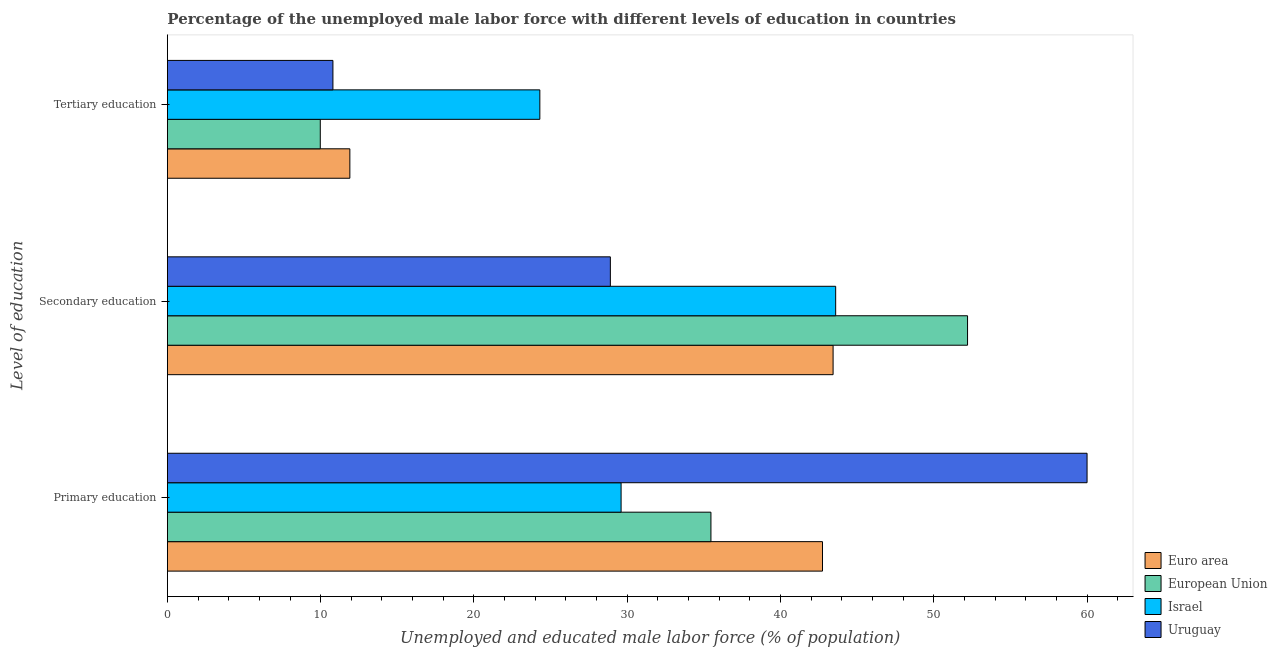Are the number of bars on each tick of the Y-axis equal?
Provide a succinct answer. Yes. How many bars are there on the 3rd tick from the bottom?
Your answer should be compact. 4. What is the label of the 2nd group of bars from the top?
Make the answer very short. Secondary education. What is the percentage of male labor force who received secondary education in Euro area?
Offer a very short reply. 43.43. Across all countries, what is the maximum percentage of male labor force who received primary education?
Give a very brief answer. 60. Across all countries, what is the minimum percentage of male labor force who received secondary education?
Make the answer very short. 28.9. In which country was the percentage of male labor force who received primary education maximum?
Your response must be concise. Uruguay. In which country was the percentage of male labor force who received secondary education minimum?
Ensure brevity in your answer.  Uruguay. What is the total percentage of male labor force who received primary education in the graph?
Your answer should be very brief. 167.8. What is the difference between the percentage of male labor force who received secondary education in Israel and that in Uruguay?
Give a very brief answer. 14.7. What is the difference between the percentage of male labor force who received primary education in European Union and the percentage of male labor force who received secondary education in Euro area?
Your answer should be very brief. -7.97. What is the average percentage of male labor force who received tertiary education per country?
Provide a short and direct response. 14.24. What is the difference between the percentage of male labor force who received tertiary education and percentage of male labor force who received primary education in Euro area?
Ensure brevity in your answer.  -30.84. In how many countries, is the percentage of male labor force who received primary education greater than 14 %?
Ensure brevity in your answer.  4. What is the ratio of the percentage of male labor force who received tertiary education in Euro area to that in Israel?
Your answer should be compact. 0.49. What is the difference between the highest and the second highest percentage of male labor force who received primary education?
Your response must be concise. 17.26. What is the difference between the highest and the lowest percentage of male labor force who received primary education?
Offer a terse response. 30.4. In how many countries, is the percentage of male labor force who received secondary education greater than the average percentage of male labor force who received secondary education taken over all countries?
Offer a terse response. 3. What does the 2nd bar from the top in Secondary education represents?
Provide a succinct answer. Israel. What does the 4th bar from the bottom in Secondary education represents?
Make the answer very short. Uruguay. Is it the case that in every country, the sum of the percentage of male labor force who received primary education and percentage of male labor force who received secondary education is greater than the percentage of male labor force who received tertiary education?
Your answer should be very brief. Yes. Are all the bars in the graph horizontal?
Offer a terse response. Yes. How many countries are there in the graph?
Keep it short and to the point. 4. What is the difference between two consecutive major ticks on the X-axis?
Your answer should be compact. 10. Are the values on the major ticks of X-axis written in scientific E-notation?
Offer a very short reply. No. Where does the legend appear in the graph?
Keep it short and to the point. Bottom right. How many legend labels are there?
Provide a short and direct response. 4. How are the legend labels stacked?
Provide a short and direct response. Vertical. What is the title of the graph?
Provide a succinct answer. Percentage of the unemployed male labor force with different levels of education in countries. Does "Iceland" appear as one of the legend labels in the graph?
Your response must be concise. No. What is the label or title of the X-axis?
Provide a short and direct response. Unemployed and educated male labor force (% of population). What is the label or title of the Y-axis?
Provide a succinct answer. Level of education. What is the Unemployed and educated male labor force (% of population) in Euro area in Primary education?
Keep it short and to the point. 42.74. What is the Unemployed and educated male labor force (% of population) in European Union in Primary education?
Provide a short and direct response. 35.46. What is the Unemployed and educated male labor force (% of population) in Israel in Primary education?
Offer a very short reply. 29.6. What is the Unemployed and educated male labor force (% of population) of Euro area in Secondary education?
Provide a succinct answer. 43.43. What is the Unemployed and educated male labor force (% of population) of European Union in Secondary education?
Your response must be concise. 52.2. What is the Unemployed and educated male labor force (% of population) in Israel in Secondary education?
Offer a terse response. 43.6. What is the Unemployed and educated male labor force (% of population) of Uruguay in Secondary education?
Your response must be concise. 28.9. What is the Unemployed and educated male labor force (% of population) of Euro area in Tertiary education?
Your response must be concise. 11.9. What is the Unemployed and educated male labor force (% of population) of European Union in Tertiary education?
Keep it short and to the point. 9.97. What is the Unemployed and educated male labor force (% of population) in Israel in Tertiary education?
Provide a short and direct response. 24.3. What is the Unemployed and educated male labor force (% of population) of Uruguay in Tertiary education?
Give a very brief answer. 10.8. Across all Level of education, what is the maximum Unemployed and educated male labor force (% of population) in Euro area?
Offer a terse response. 43.43. Across all Level of education, what is the maximum Unemployed and educated male labor force (% of population) of European Union?
Make the answer very short. 52.2. Across all Level of education, what is the maximum Unemployed and educated male labor force (% of population) in Israel?
Your answer should be very brief. 43.6. Across all Level of education, what is the minimum Unemployed and educated male labor force (% of population) in Euro area?
Provide a succinct answer. 11.9. Across all Level of education, what is the minimum Unemployed and educated male labor force (% of population) of European Union?
Your answer should be compact. 9.97. Across all Level of education, what is the minimum Unemployed and educated male labor force (% of population) in Israel?
Give a very brief answer. 24.3. Across all Level of education, what is the minimum Unemployed and educated male labor force (% of population) in Uruguay?
Your answer should be very brief. 10.8. What is the total Unemployed and educated male labor force (% of population) in Euro area in the graph?
Provide a succinct answer. 98.08. What is the total Unemployed and educated male labor force (% of population) in European Union in the graph?
Offer a terse response. 97.64. What is the total Unemployed and educated male labor force (% of population) of Israel in the graph?
Your answer should be compact. 97.5. What is the total Unemployed and educated male labor force (% of population) in Uruguay in the graph?
Your answer should be compact. 99.7. What is the difference between the Unemployed and educated male labor force (% of population) of Euro area in Primary education and that in Secondary education?
Provide a succinct answer. -0.69. What is the difference between the Unemployed and educated male labor force (% of population) of European Union in Primary education and that in Secondary education?
Offer a very short reply. -16.74. What is the difference between the Unemployed and educated male labor force (% of population) in Israel in Primary education and that in Secondary education?
Offer a very short reply. -14. What is the difference between the Unemployed and educated male labor force (% of population) of Uruguay in Primary education and that in Secondary education?
Provide a short and direct response. 31.1. What is the difference between the Unemployed and educated male labor force (% of population) of Euro area in Primary education and that in Tertiary education?
Provide a succinct answer. 30.84. What is the difference between the Unemployed and educated male labor force (% of population) in European Union in Primary education and that in Tertiary education?
Provide a short and direct response. 25.49. What is the difference between the Unemployed and educated male labor force (% of population) in Israel in Primary education and that in Tertiary education?
Give a very brief answer. 5.3. What is the difference between the Unemployed and educated male labor force (% of population) of Uruguay in Primary education and that in Tertiary education?
Your response must be concise. 49.2. What is the difference between the Unemployed and educated male labor force (% of population) in Euro area in Secondary education and that in Tertiary education?
Make the answer very short. 31.53. What is the difference between the Unemployed and educated male labor force (% of population) in European Union in Secondary education and that in Tertiary education?
Your answer should be very brief. 42.23. What is the difference between the Unemployed and educated male labor force (% of population) in Israel in Secondary education and that in Tertiary education?
Your answer should be very brief. 19.3. What is the difference between the Unemployed and educated male labor force (% of population) in Euro area in Primary education and the Unemployed and educated male labor force (% of population) in European Union in Secondary education?
Keep it short and to the point. -9.46. What is the difference between the Unemployed and educated male labor force (% of population) in Euro area in Primary education and the Unemployed and educated male labor force (% of population) in Israel in Secondary education?
Give a very brief answer. -0.86. What is the difference between the Unemployed and educated male labor force (% of population) of Euro area in Primary education and the Unemployed and educated male labor force (% of population) of Uruguay in Secondary education?
Your answer should be very brief. 13.84. What is the difference between the Unemployed and educated male labor force (% of population) in European Union in Primary education and the Unemployed and educated male labor force (% of population) in Israel in Secondary education?
Keep it short and to the point. -8.14. What is the difference between the Unemployed and educated male labor force (% of population) of European Union in Primary education and the Unemployed and educated male labor force (% of population) of Uruguay in Secondary education?
Your answer should be compact. 6.56. What is the difference between the Unemployed and educated male labor force (% of population) in Israel in Primary education and the Unemployed and educated male labor force (% of population) in Uruguay in Secondary education?
Make the answer very short. 0.7. What is the difference between the Unemployed and educated male labor force (% of population) of Euro area in Primary education and the Unemployed and educated male labor force (% of population) of European Union in Tertiary education?
Make the answer very short. 32.77. What is the difference between the Unemployed and educated male labor force (% of population) of Euro area in Primary education and the Unemployed and educated male labor force (% of population) of Israel in Tertiary education?
Your response must be concise. 18.44. What is the difference between the Unemployed and educated male labor force (% of population) in Euro area in Primary education and the Unemployed and educated male labor force (% of population) in Uruguay in Tertiary education?
Provide a succinct answer. 31.94. What is the difference between the Unemployed and educated male labor force (% of population) in European Union in Primary education and the Unemployed and educated male labor force (% of population) in Israel in Tertiary education?
Provide a succinct answer. 11.16. What is the difference between the Unemployed and educated male labor force (% of population) of European Union in Primary education and the Unemployed and educated male labor force (% of population) of Uruguay in Tertiary education?
Give a very brief answer. 24.66. What is the difference between the Unemployed and educated male labor force (% of population) in Israel in Primary education and the Unemployed and educated male labor force (% of population) in Uruguay in Tertiary education?
Offer a very short reply. 18.8. What is the difference between the Unemployed and educated male labor force (% of population) in Euro area in Secondary education and the Unemployed and educated male labor force (% of population) in European Union in Tertiary education?
Ensure brevity in your answer.  33.46. What is the difference between the Unemployed and educated male labor force (% of population) in Euro area in Secondary education and the Unemployed and educated male labor force (% of population) in Israel in Tertiary education?
Keep it short and to the point. 19.13. What is the difference between the Unemployed and educated male labor force (% of population) in Euro area in Secondary education and the Unemployed and educated male labor force (% of population) in Uruguay in Tertiary education?
Give a very brief answer. 32.63. What is the difference between the Unemployed and educated male labor force (% of population) of European Union in Secondary education and the Unemployed and educated male labor force (% of population) of Israel in Tertiary education?
Keep it short and to the point. 27.9. What is the difference between the Unemployed and educated male labor force (% of population) of European Union in Secondary education and the Unemployed and educated male labor force (% of population) of Uruguay in Tertiary education?
Keep it short and to the point. 41.4. What is the difference between the Unemployed and educated male labor force (% of population) in Israel in Secondary education and the Unemployed and educated male labor force (% of population) in Uruguay in Tertiary education?
Your answer should be compact. 32.8. What is the average Unemployed and educated male labor force (% of population) in Euro area per Level of education?
Your answer should be very brief. 32.69. What is the average Unemployed and educated male labor force (% of population) in European Union per Level of education?
Make the answer very short. 32.55. What is the average Unemployed and educated male labor force (% of population) of Israel per Level of education?
Offer a very short reply. 32.5. What is the average Unemployed and educated male labor force (% of population) in Uruguay per Level of education?
Your response must be concise. 33.23. What is the difference between the Unemployed and educated male labor force (% of population) in Euro area and Unemployed and educated male labor force (% of population) in European Union in Primary education?
Provide a short and direct response. 7.28. What is the difference between the Unemployed and educated male labor force (% of population) in Euro area and Unemployed and educated male labor force (% of population) in Israel in Primary education?
Give a very brief answer. 13.14. What is the difference between the Unemployed and educated male labor force (% of population) in Euro area and Unemployed and educated male labor force (% of population) in Uruguay in Primary education?
Ensure brevity in your answer.  -17.26. What is the difference between the Unemployed and educated male labor force (% of population) of European Union and Unemployed and educated male labor force (% of population) of Israel in Primary education?
Offer a terse response. 5.86. What is the difference between the Unemployed and educated male labor force (% of population) in European Union and Unemployed and educated male labor force (% of population) in Uruguay in Primary education?
Make the answer very short. -24.54. What is the difference between the Unemployed and educated male labor force (% of population) in Israel and Unemployed and educated male labor force (% of population) in Uruguay in Primary education?
Ensure brevity in your answer.  -30.4. What is the difference between the Unemployed and educated male labor force (% of population) in Euro area and Unemployed and educated male labor force (% of population) in European Union in Secondary education?
Your answer should be compact. -8.77. What is the difference between the Unemployed and educated male labor force (% of population) of Euro area and Unemployed and educated male labor force (% of population) of Israel in Secondary education?
Offer a very short reply. -0.17. What is the difference between the Unemployed and educated male labor force (% of population) in Euro area and Unemployed and educated male labor force (% of population) in Uruguay in Secondary education?
Keep it short and to the point. 14.53. What is the difference between the Unemployed and educated male labor force (% of population) of European Union and Unemployed and educated male labor force (% of population) of Israel in Secondary education?
Keep it short and to the point. 8.6. What is the difference between the Unemployed and educated male labor force (% of population) of European Union and Unemployed and educated male labor force (% of population) of Uruguay in Secondary education?
Make the answer very short. 23.3. What is the difference between the Unemployed and educated male labor force (% of population) of Israel and Unemployed and educated male labor force (% of population) of Uruguay in Secondary education?
Keep it short and to the point. 14.7. What is the difference between the Unemployed and educated male labor force (% of population) in Euro area and Unemployed and educated male labor force (% of population) in European Union in Tertiary education?
Give a very brief answer. 1.93. What is the difference between the Unemployed and educated male labor force (% of population) of Euro area and Unemployed and educated male labor force (% of population) of Israel in Tertiary education?
Provide a short and direct response. -12.39. What is the difference between the Unemployed and educated male labor force (% of population) of Euro area and Unemployed and educated male labor force (% of population) of Uruguay in Tertiary education?
Ensure brevity in your answer.  1.1. What is the difference between the Unemployed and educated male labor force (% of population) in European Union and Unemployed and educated male labor force (% of population) in Israel in Tertiary education?
Provide a short and direct response. -14.33. What is the difference between the Unemployed and educated male labor force (% of population) in European Union and Unemployed and educated male labor force (% of population) in Uruguay in Tertiary education?
Make the answer very short. -0.83. What is the difference between the Unemployed and educated male labor force (% of population) in Israel and Unemployed and educated male labor force (% of population) in Uruguay in Tertiary education?
Provide a succinct answer. 13.5. What is the ratio of the Unemployed and educated male labor force (% of population) of Euro area in Primary education to that in Secondary education?
Your response must be concise. 0.98. What is the ratio of the Unemployed and educated male labor force (% of population) in European Union in Primary education to that in Secondary education?
Provide a succinct answer. 0.68. What is the ratio of the Unemployed and educated male labor force (% of population) in Israel in Primary education to that in Secondary education?
Provide a succinct answer. 0.68. What is the ratio of the Unemployed and educated male labor force (% of population) of Uruguay in Primary education to that in Secondary education?
Ensure brevity in your answer.  2.08. What is the ratio of the Unemployed and educated male labor force (% of population) of Euro area in Primary education to that in Tertiary education?
Offer a very short reply. 3.59. What is the ratio of the Unemployed and educated male labor force (% of population) of European Union in Primary education to that in Tertiary education?
Your answer should be very brief. 3.56. What is the ratio of the Unemployed and educated male labor force (% of population) in Israel in Primary education to that in Tertiary education?
Provide a short and direct response. 1.22. What is the ratio of the Unemployed and educated male labor force (% of population) of Uruguay in Primary education to that in Tertiary education?
Your answer should be compact. 5.56. What is the ratio of the Unemployed and educated male labor force (% of population) of Euro area in Secondary education to that in Tertiary education?
Your response must be concise. 3.65. What is the ratio of the Unemployed and educated male labor force (% of population) in European Union in Secondary education to that in Tertiary education?
Your answer should be compact. 5.23. What is the ratio of the Unemployed and educated male labor force (% of population) in Israel in Secondary education to that in Tertiary education?
Make the answer very short. 1.79. What is the ratio of the Unemployed and educated male labor force (% of population) in Uruguay in Secondary education to that in Tertiary education?
Your response must be concise. 2.68. What is the difference between the highest and the second highest Unemployed and educated male labor force (% of population) of Euro area?
Your answer should be very brief. 0.69. What is the difference between the highest and the second highest Unemployed and educated male labor force (% of population) of European Union?
Your answer should be very brief. 16.74. What is the difference between the highest and the second highest Unemployed and educated male labor force (% of population) in Israel?
Provide a succinct answer. 14. What is the difference between the highest and the second highest Unemployed and educated male labor force (% of population) of Uruguay?
Provide a short and direct response. 31.1. What is the difference between the highest and the lowest Unemployed and educated male labor force (% of population) in Euro area?
Your response must be concise. 31.53. What is the difference between the highest and the lowest Unemployed and educated male labor force (% of population) in European Union?
Make the answer very short. 42.23. What is the difference between the highest and the lowest Unemployed and educated male labor force (% of population) of Israel?
Make the answer very short. 19.3. What is the difference between the highest and the lowest Unemployed and educated male labor force (% of population) in Uruguay?
Make the answer very short. 49.2. 